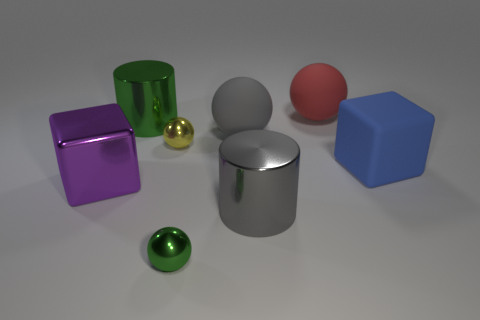What number of other objects are the same shape as the big red object?
Provide a succinct answer. 3. What is the shape of the green metallic object behind the small yellow shiny sphere?
Keep it short and to the point. Cylinder. Are there any big gray objects that have the same material as the tiny green sphere?
Ensure brevity in your answer.  Yes. There is a big cylinder that is behind the large purple cube; does it have the same color as the metal block?
Your response must be concise. No. What is the size of the red rubber sphere?
Your answer should be very brief. Large. There is a green object that is behind the big rubber object that is to the right of the large red thing; are there any purple blocks that are behind it?
Your response must be concise. No. There is a yellow thing; what number of purple shiny objects are right of it?
Your response must be concise. 0. What number of other matte cubes have the same color as the big rubber block?
Your answer should be very brief. 0. How many things are big gray things that are in front of the blue rubber block or cylinders that are in front of the gray rubber object?
Your response must be concise. 1. Are there more purple metal cubes than metallic cylinders?
Offer a very short reply. No. 